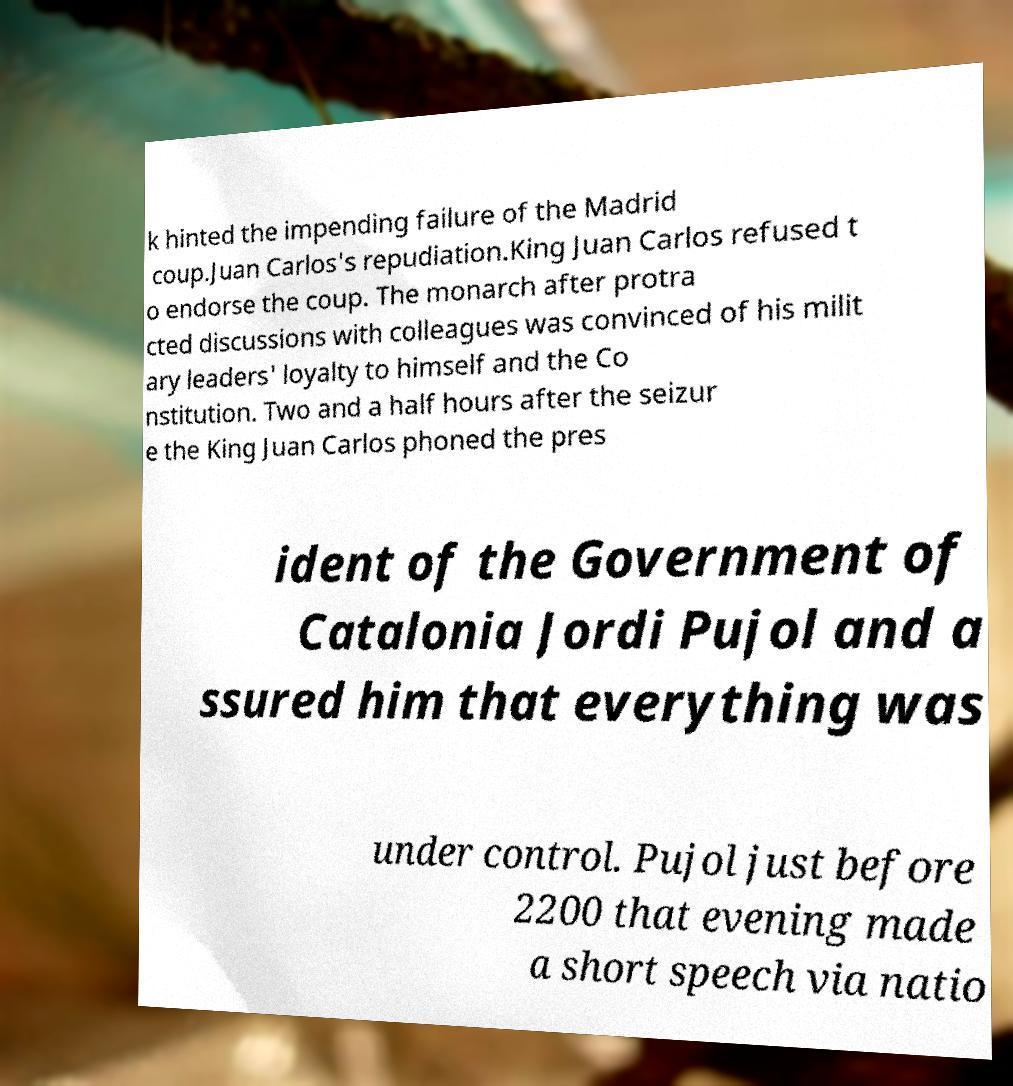For documentation purposes, I need the text within this image transcribed. Could you provide that? k hinted the impending failure of the Madrid coup.Juan Carlos's repudiation.King Juan Carlos refused t o endorse the coup. The monarch after protra cted discussions with colleagues was convinced of his milit ary leaders' loyalty to himself and the Co nstitution. Two and a half hours after the seizur e the King Juan Carlos phoned the pres ident of the Government of Catalonia Jordi Pujol and a ssured him that everything was under control. Pujol just before 2200 that evening made a short speech via natio 